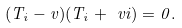Convert formula to latex. <formula><loc_0><loc_0><loc_500><loc_500>( T _ { i } - v ) ( T _ { i } + \ v i ) = 0 .</formula> 